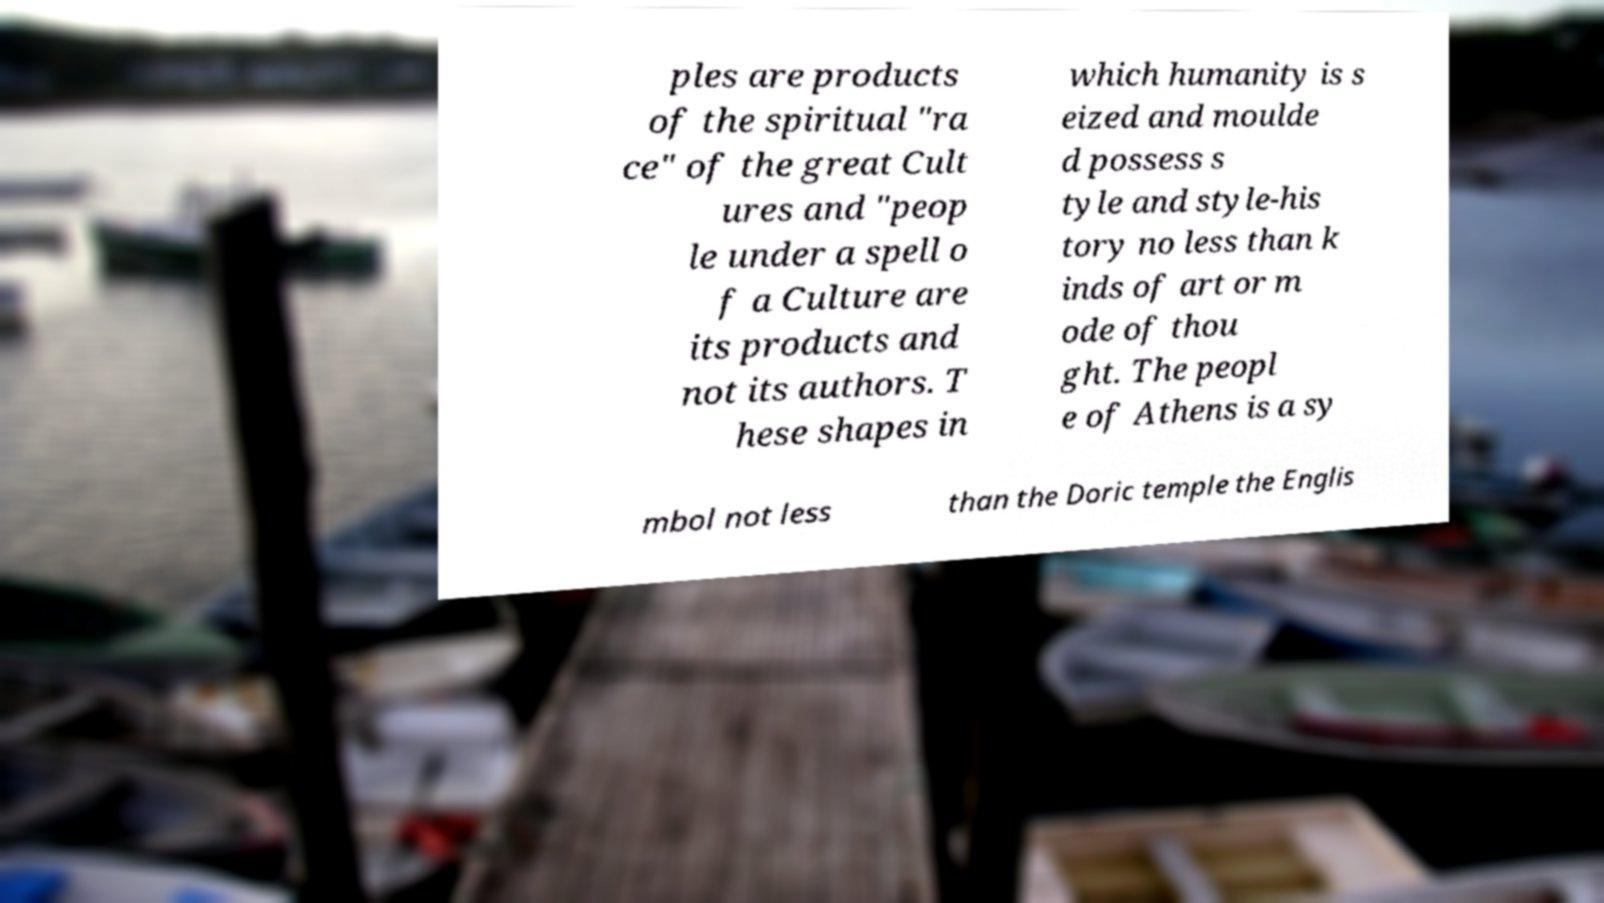Please read and relay the text visible in this image. What does it say? ples are products of the spiritual "ra ce" of the great Cult ures and "peop le under a spell o f a Culture are its products and not its authors. T hese shapes in which humanity is s eized and moulde d possess s tyle and style-his tory no less than k inds of art or m ode of thou ght. The peopl e of Athens is a sy mbol not less than the Doric temple the Englis 